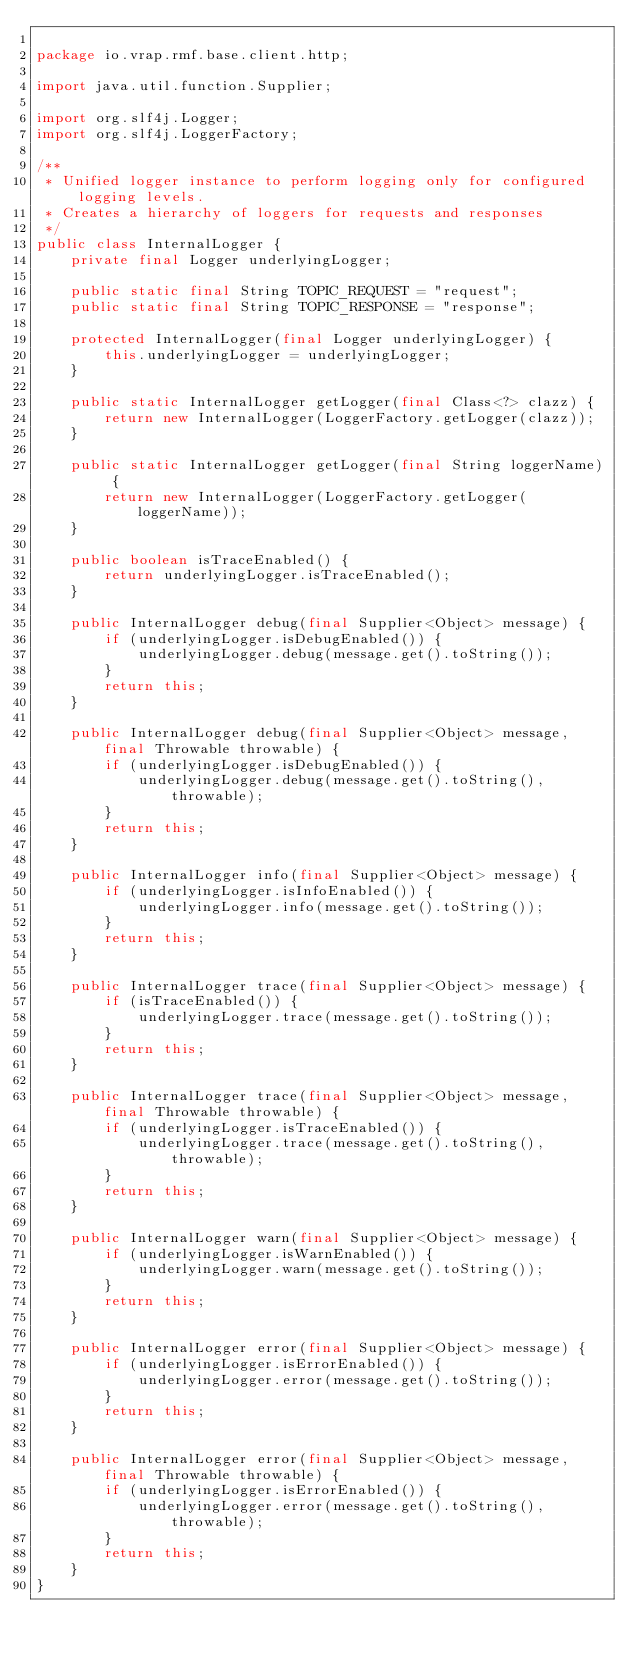Convert code to text. <code><loc_0><loc_0><loc_500><loc_500><_Java_>
package io.vrap.rmf.base.client.http;

import java.util.function.Supplier;

import org.slf4j.Logger;
import org.slf4j.LoggerFactory;

/**
 * Unified logger instance to perform logging only for configured logging levels.
 * Creates a hierarchy of loggers for requests and responses
 */
public class InternalLogger {
    private final Logger underlyingLogger;

    public static final String TOPIC_REQUEST = "request";
    public static final String TOPIC_RESPONSE = "response";

    protected InternalLogger(final Logger underlyingLogger) {
        this.underlyingLogger = underlyingLogger;
    }

    public static InternalLogger getLogger(final Class<?> clazz) {
        return new InternalLogger(LoggerFactory.getLogger(clazz));
    }

    public static InternalLogger getLogger(final String loggerName) {
        return new InternalLogger(LoggerFactory.getLogger(loggerName));
    }

    public boolean isTraceEnabled() {
        return underlyingLogger.isTraceEnabled();
    }

    public InternalLogger debug(final Supplier<Object> message) {
        if (underlyingLogger.isDebugEnabled()) {
            underlyingLogger.debug(message.get().toString());
        }
        return this;
    }

    public InternalLogger debug(final Supplier<Object> message, final Throwable throwable) {
        if (underlyingLogger.isDebugEnabled()) {
            underlyingLogger.debug(message.get().toString(), throwable);
        }
        return this;
    }

    public InternalLogger info(final Supplier<Object> message) {
        if (underlyingLogger.isInfoEnabled()) {
            underlyingLogger.info(message.get().toString());
        }
        return this;
    }

    public InternalLogger trace(final Supplier<Object> message) {
        if (isTraceEnabled()) {
            underlyingLogger.trace(message.get().toString());
        }
        return this;
    }

    public InternalLogger trace(final Supplier<Object> message, final Throwable throwable) {
        if (underlyingLogger.isTraceEnabled()) {
            underlyingLogger.trace(message.get().toString(), throwable);
        }
        return this;
    }

    public InternalLogger warn(final Supplier<Object> message) {
        if (underlyingLogger.isWarnEnabled()) {
            underlyingLogger.warn(message.get().toString());
        }
        return this;
    }

    public InternalLogger error(final Supplier<Object> message) {
        if (underlyingLogger.isErrorEnabled()) {
            underlyingLogger.error(message.get().toString());
        }
        return this;
    }

    public InternalLogger error(final Supplier<Object> message, final Throwable throwable) {
        if (underlyingLogger.isErrorEnabled()) {
            underlyingLogger.error(message.get().toString(), throwable);
        }
        return this;
    }
}
</code> 